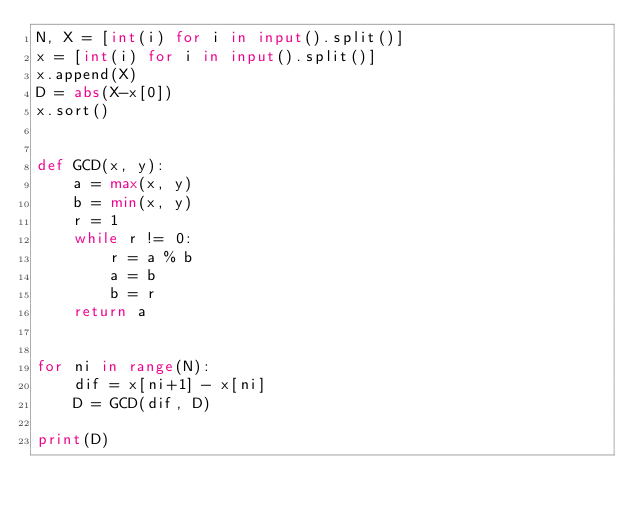Convert code to text. <code><loc_0><loc_0><loc_500><loc_500><_Python_>N, X = [int(i) for i in input().split()]
x = [int(i) for i in input().split()]
x.append(X)
D = abs(X-x[0])
x.sort()


def GCD(x, y):
    a = max(x, y)
    b = min(x, y)
    r = 1
    while r != 0:
        r = a % b
        a = b
        b = r
    return a


for ni in range(N):
    dif = x[ni+1] - x[ni]
    D = GCD(dif, D)

print(D)</code> 